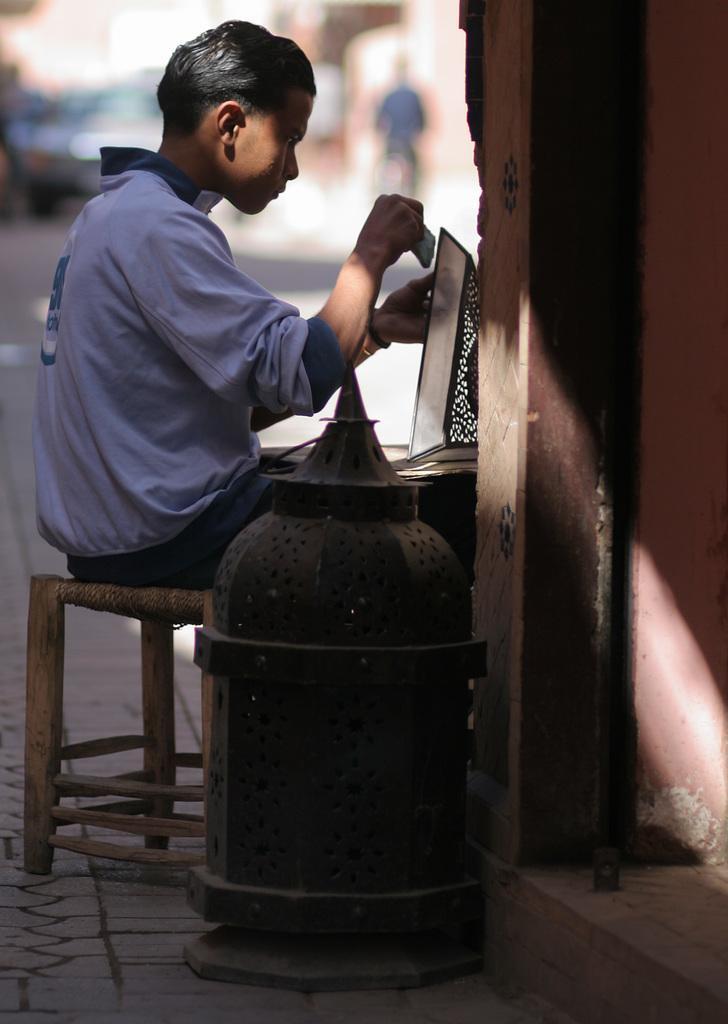How would you summarize this image in a sentence or two? In this picture, we see the man in white T-shirt is sitting on the chair. He might be painting or carving. Beside him, we see a metal box. On the right side, we see the wall. In the background, we see buildings, car and a man riding the bicycle. This picture is blurred in the background. 